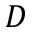Convert formula to latex. <formula><loc_0><loc_0><loc_500><loc_500>D</formula> 